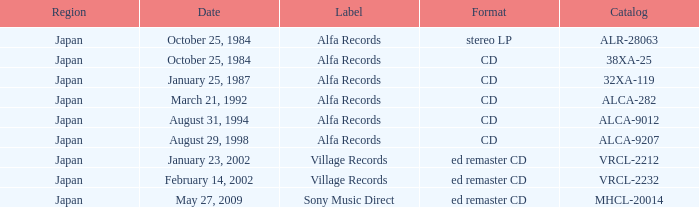What Label released on October 25, 1984, in the format of Stereo LP? Alfa Records. 